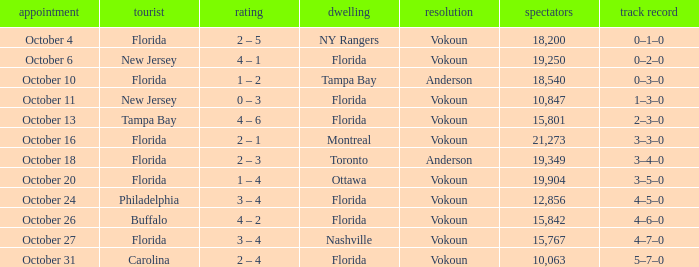Which team was home on October 13? Florida. 